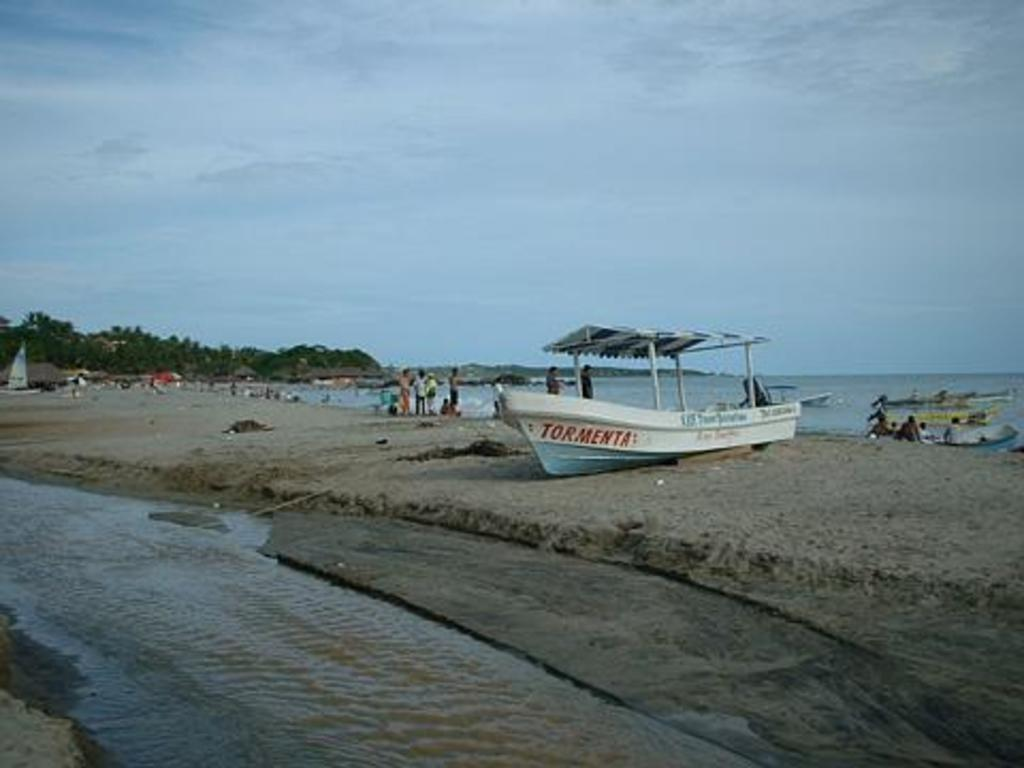What is the main subject of the image? The main subject of the image is water. What can be seen floating on the water? There are boats in the image. What type of vegetation is visible in the background of the image? There are trees in the background of the image. What is visible in the sky in the background of the image? There are clouds in the sky in the background of the image. Where is the honey stored in the image? There is no honey present in the image. What color is the scarf that the person in the image is wearing? There are no people or scarves present in the image. 